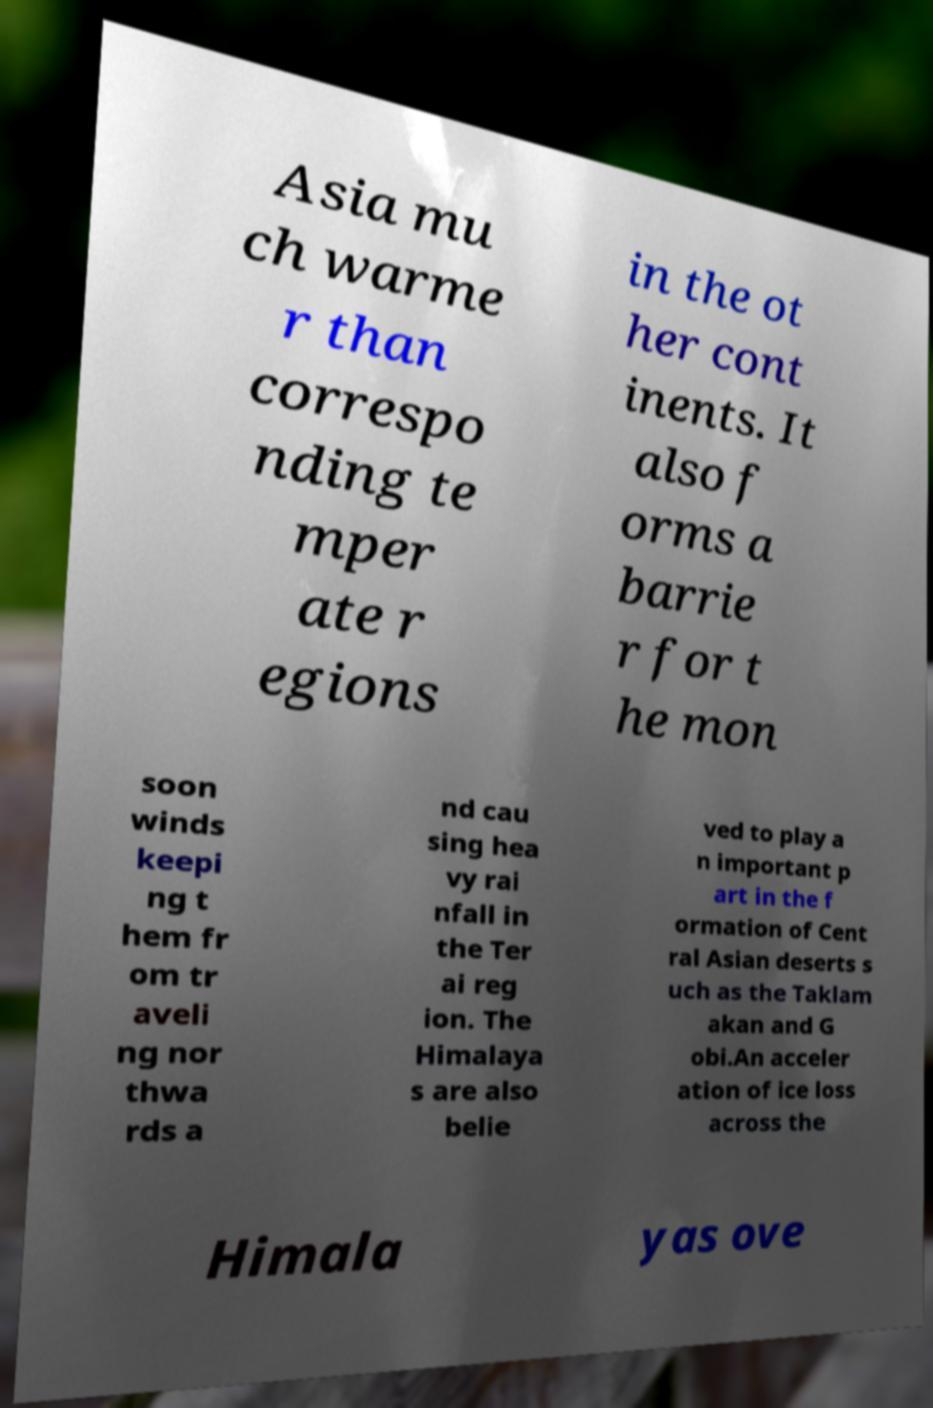Please identify and transcribe the text found in this image. Asia mu ch warme r than correspo nding te mper ate r egions in the ot her cont inents. It also f orms a barrie r for t he mon soon winds keepi ng t hem fr om tr aveli ng nor thwa rds a nd cau sing hea vy rai nfall in the Ter ai reg ion. The Himalaya s are also belie ved to play a n important p art in the f ormation of Cent ral Asian deserts s uch as the Taklam akan and G obi.An acceler ation of ice loss across the Himala yas ove 